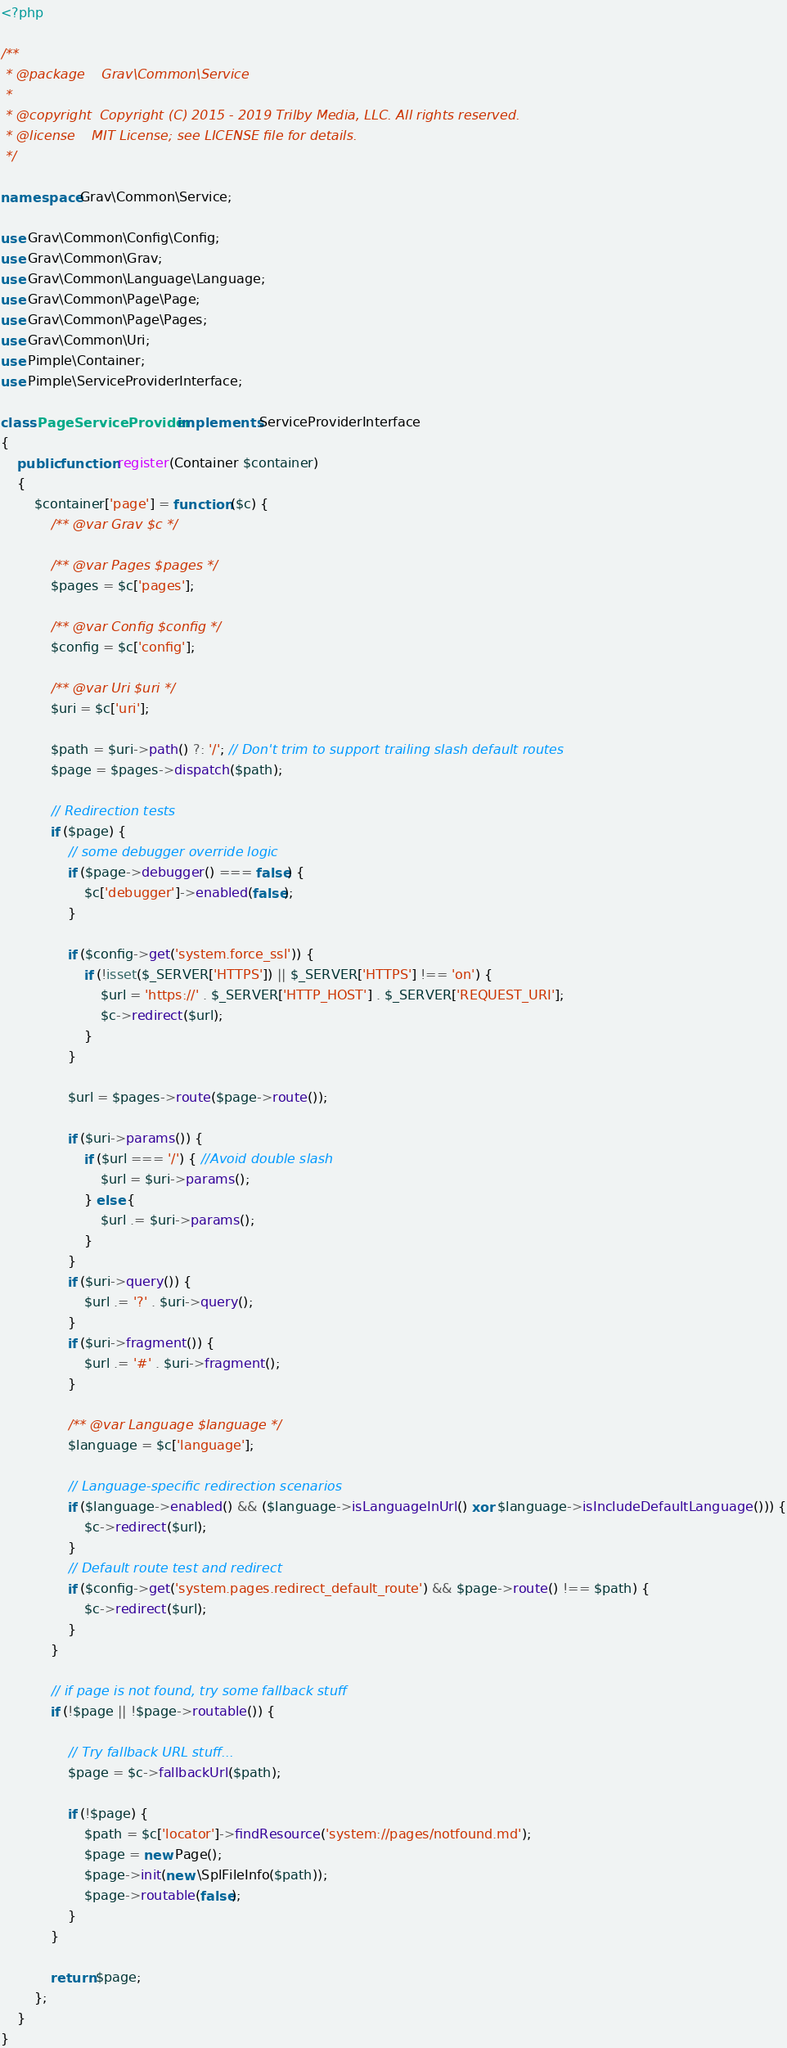Convert code to text. <code><loc_0><loc_0><loc_500><loc_500><_PHP_><?php

/**
 * @package    Grav\Common\Service
 *
 * @copyright  Copyright (C) 2015 - 2019 Trilby Media, LLC. All rights reserved.
 * @license    MIT License; see LICENSE file for details.
 */

namespace Grav\Common\Service;

use Grav\Common\Config\Config;
use Grav\Common\Grav;
use Grav\Common\Language\Language;
use Grav\Common\Page\Page;
use Grav\Common\Page\Pages;
use Grav\Common\Uri;
use Pimple\Container;
use Pimple\ServiceProviderInterface;

class PageServiceProvider implements ServiceProviderInterface
{
    public function register(Container $container)
    {
        $container['page'] = function ($c) {
            /** @var Grav $c */

            /** @var Pages $pages */
            $pages = $c['pages'];

            /** @var Config $config */
            $config = $c['config'];

            /** @var Uri $uri */
            $uri = $c['uri'];

            $path = $uri->path() ?: '/'; // Don't trim to support trailing slash default routes
            $page = $pages->dispatch($path);

            // Redirection tests
            if ($page) {
                // some debugger override logic
                if ($page->debugger() === false) {
                    $c['debugger']->enabled(false);
                }

                if ($config->get('system.force_ssl')) {
                    if (!isset($_SERVER['HTTPS']) || $_SERVER['HTTPS'] !== 'on') {
                        $url = 'https://' . $_SERVER['HTTP_HOST'] . $_SERVER['REQUEST_URI'];
                        $c->redirect($url);
                    }
                }

                $url = $pages->route($page->route());

                if ($uri->params()) {
                    if ($url === '/') { //Avoid double slash
                        $url = $uri->params();
                    } else {
                        $url .= $uri->params();
                    }
                }
                if ($uri->query()) {
                    $url .= '?' . $uri->query();
                }
                if ($uri->fragment()) {
                    $url .= '#' . $uri->fragment();
                }

                /** @var Language $language */
                $language = $c['language'];

                // Language-specific redirection scenarios
                if ($language->enabled() && ($language->isLanguageInUrl() xor $language->isIncludeDefaultLanguage())) {
                    $c->redirect($url);
                }
                // Default route test and redirect
                if ($config->get('system.pages.redirect_default_route') && $page->route() !== $path) {
                    $c->redirect($url);
                }
            }

            // if page is not found, try some fallback stuff
            if (!$page || !$page->routable()) {

                // Try fallback URL stuff...
                $page = $c->fallbackUrl($path);

                if (!$page) {
                    $path = $c['locator']->findResource('system://pages/notfound.md');
                    $page = new Page();
                    $page->init(new \SplFileInfo($path));
                    $page->routable(false);
                }
            }

            return $page;
        };
    }
}
</code> 